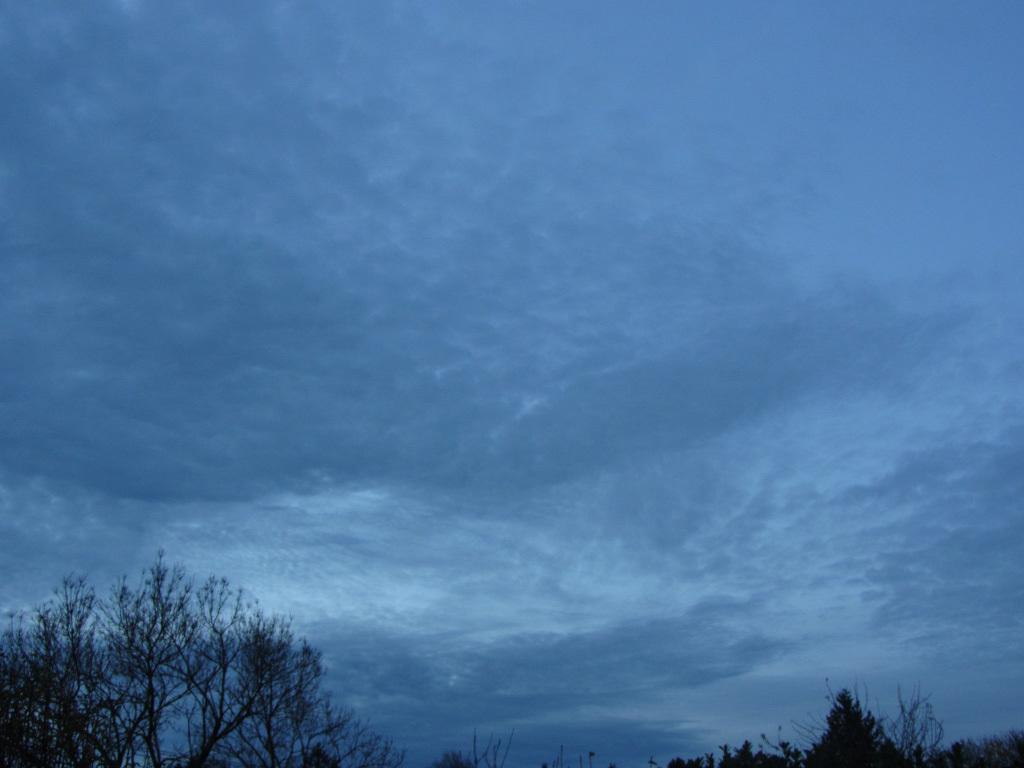In one or two sentences, can you explain what this image depicts? In this image we can see the sky which looks cloudy. On the bottom of the image we can see a group of trees. 